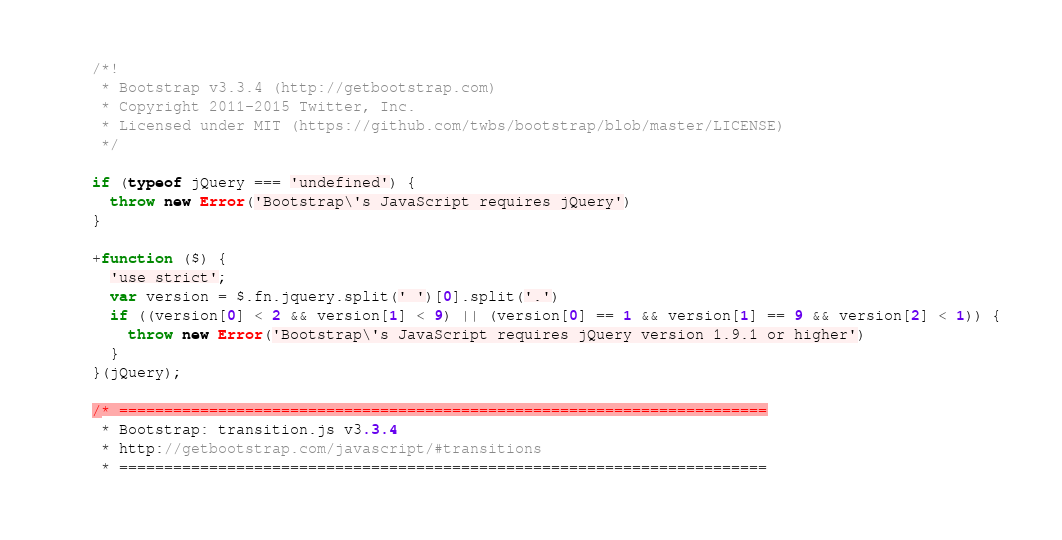<code> <loc_0><loc_0><loc_500><loc_500><_JavaScript_>/*!
 * Bootstrap v3.3.4 (http://getbootstrap.com)
 * Copyright 2011-2015 Twitter, Inc.
 * Licensed under MIT (https://github.com/twbs/bootstrap/blob/master/LICENSE)
 */

if (typeof jQuery === 'undefined') {
  throw new Error('Bootstrap\'s JavaScript requires jQuery')
}

+function ($) {
  'use strict';
  var version = $.fn.jquery.split(' ')[0].split('.')
  if ((version[0] < 2 && version[1] < 9) || (version[0] == 1 && version[1] == 9 && version[2] < 1)) {
    throw new Error('Bootstrap\'s JavaScript requires jQuery version 1.9.1 or higher')
  }
}(jQuery);

/* ========================================================================
 * Bootstrap: transition.js v3.3.4
 * http://getbootstrap.com/javascript/#transitions
 * ========================================================================</code> 